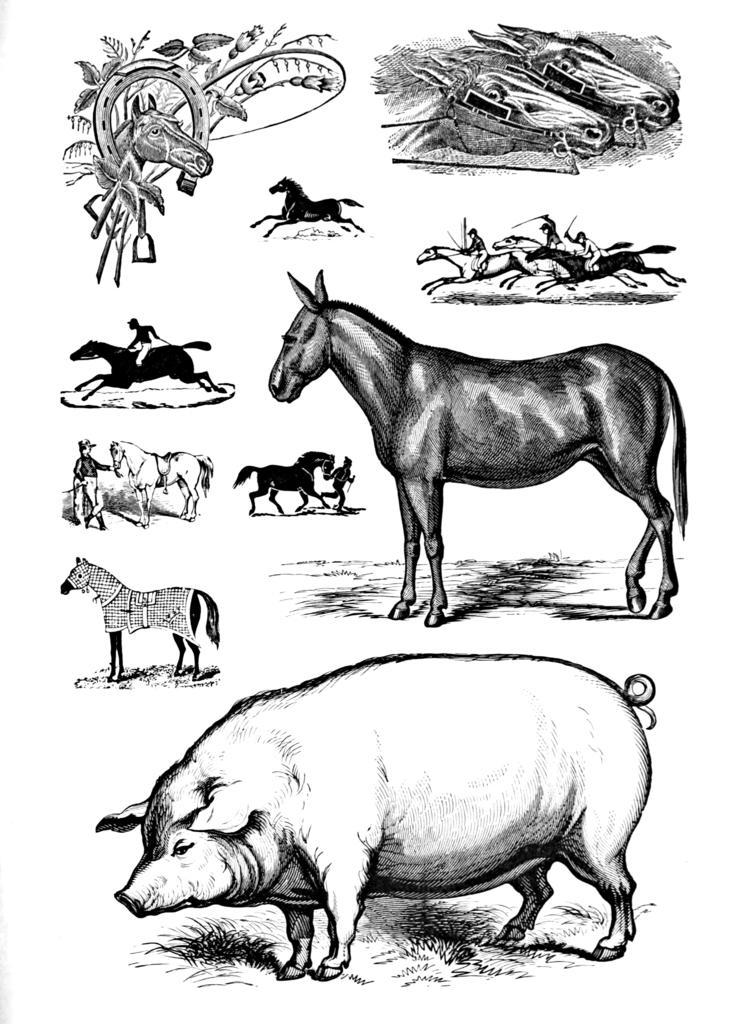Please provide a concise description of this image. In the foreground of this poster, we can see the sketch of few animals. 